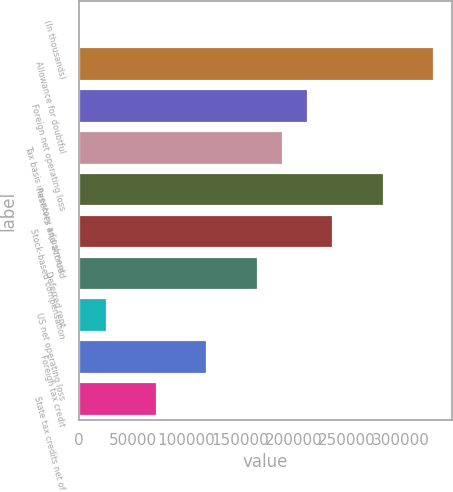Convert chart to OTSL. <chart><loc_0><loc_0><loc_500><loc_500><bar_chart><fcel>(In thousands)<fcel>Allowance for doubtful<fcel>Foreign net operating loss<fcel>Tax basis inventory adjustment<fcel>Reserves and accrued<fcel>Stock-based compensation<fcel>Deferred rent<fcel>US net operating loss<fcel>Foreign tax credit<fcel>State tax credits net of<nl><fcel>2016<fcel>331187<fcel>213626<fcel>190114<fcel>284162<fcel>237138<fcel>166601<fcel>25528.2<fcel>119577<fcel>72552.6<nl></chart> 